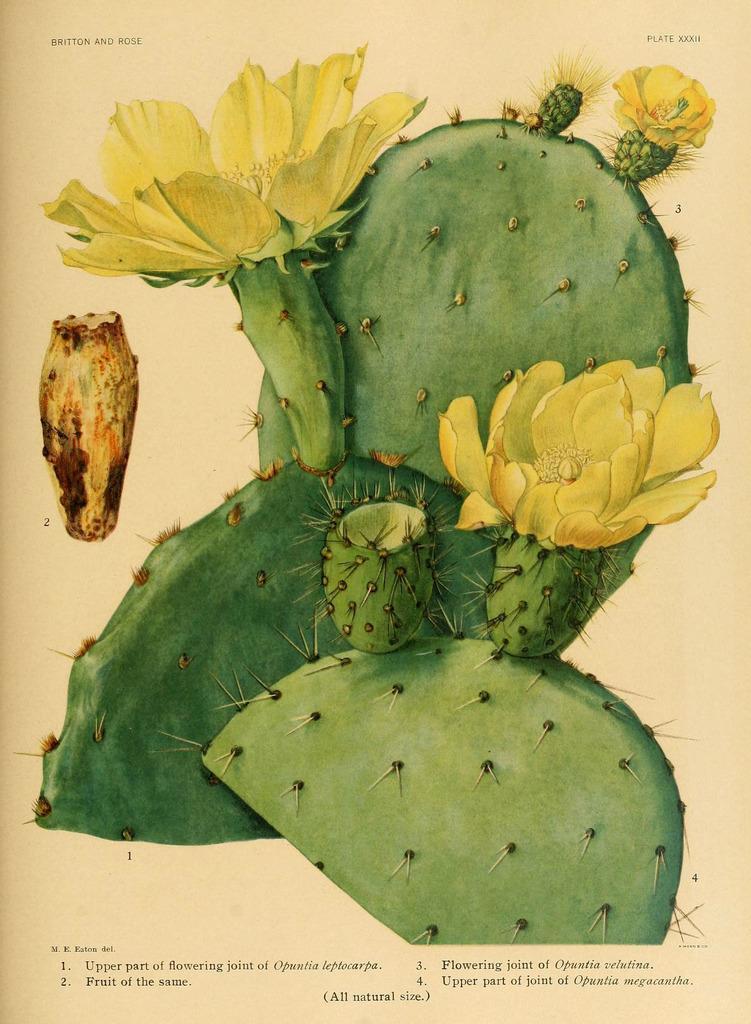In one or two sentences, can you explain what this image depicts? This image consists of a poster. In the middle there are flowers, plants. At the bottom and top there is a text. 